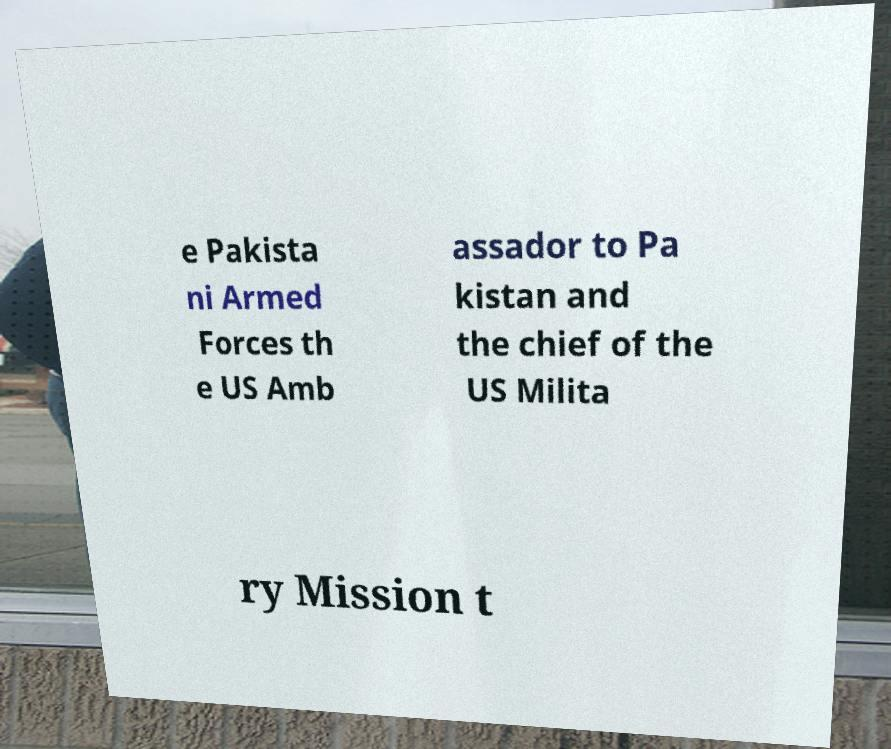What messages or text are displayed in this image? I need them in a readable, typed format. e Pakista ni Armed Forces th e US Amb assador to Pa kistan and the chief of the US Milita ry Mission t 